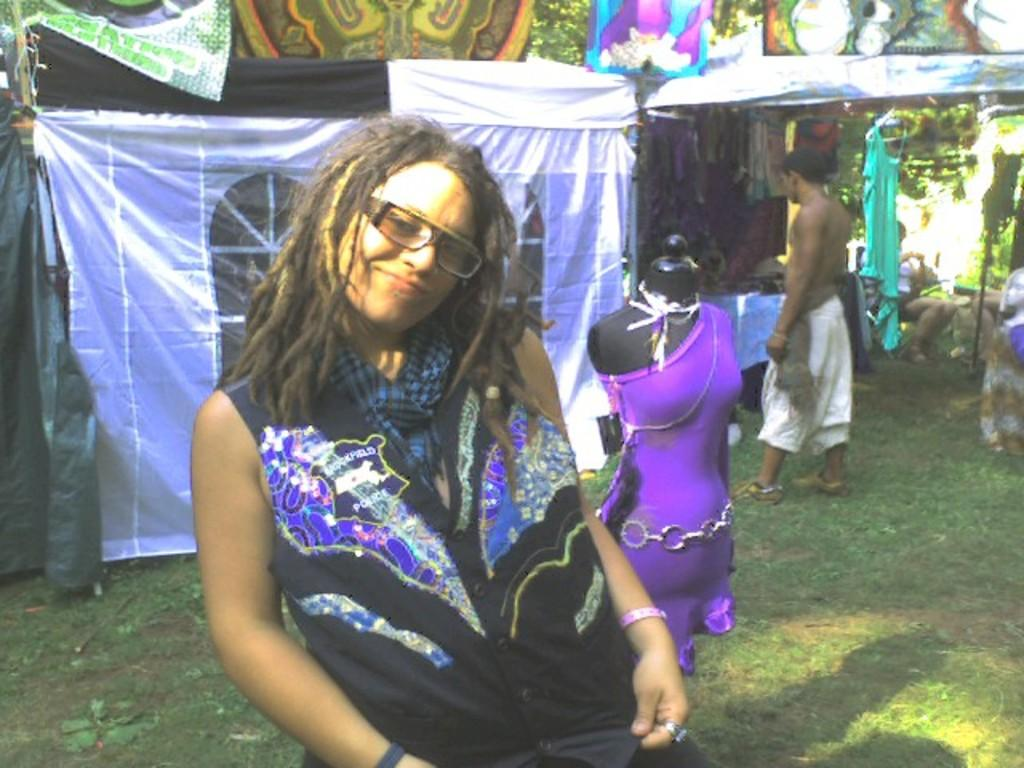What is the person in the image wearing on their face? The person in the image is wearing glasses. What type of object can be seen in the image that resembles a human figure? There is a mannequin in the image. What type of items are visible in the image that people wear? There are clothes visible in the image. What type of natural environment is present in the image? There is grass in the image. What type of shelter is present in the image? There is a tent in the image. Can you see any lace on the mannequin's clothing in the image? There is no mention of lace in the provided facts, and therefore we cannot determine if it is present in the image. 